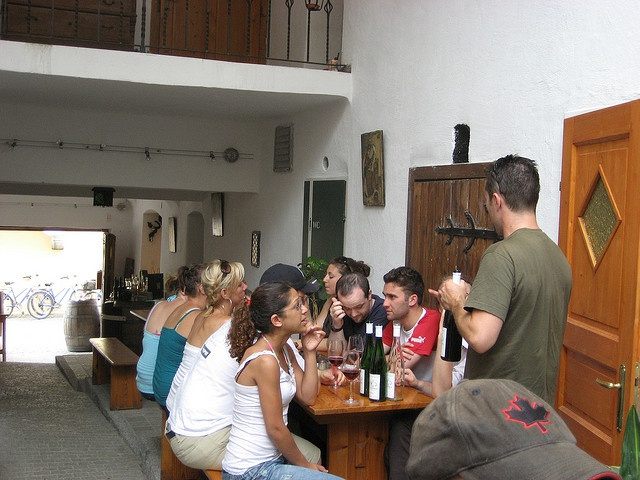Describe the objects in this image and their specific colors. I can see people in black and gray tones, people in black, white, brown, and tan tones, people in black and gray tones, people in black, white, darkgray, and lightgray tones, and dining table in black, maroon, and brown tones in this image. 